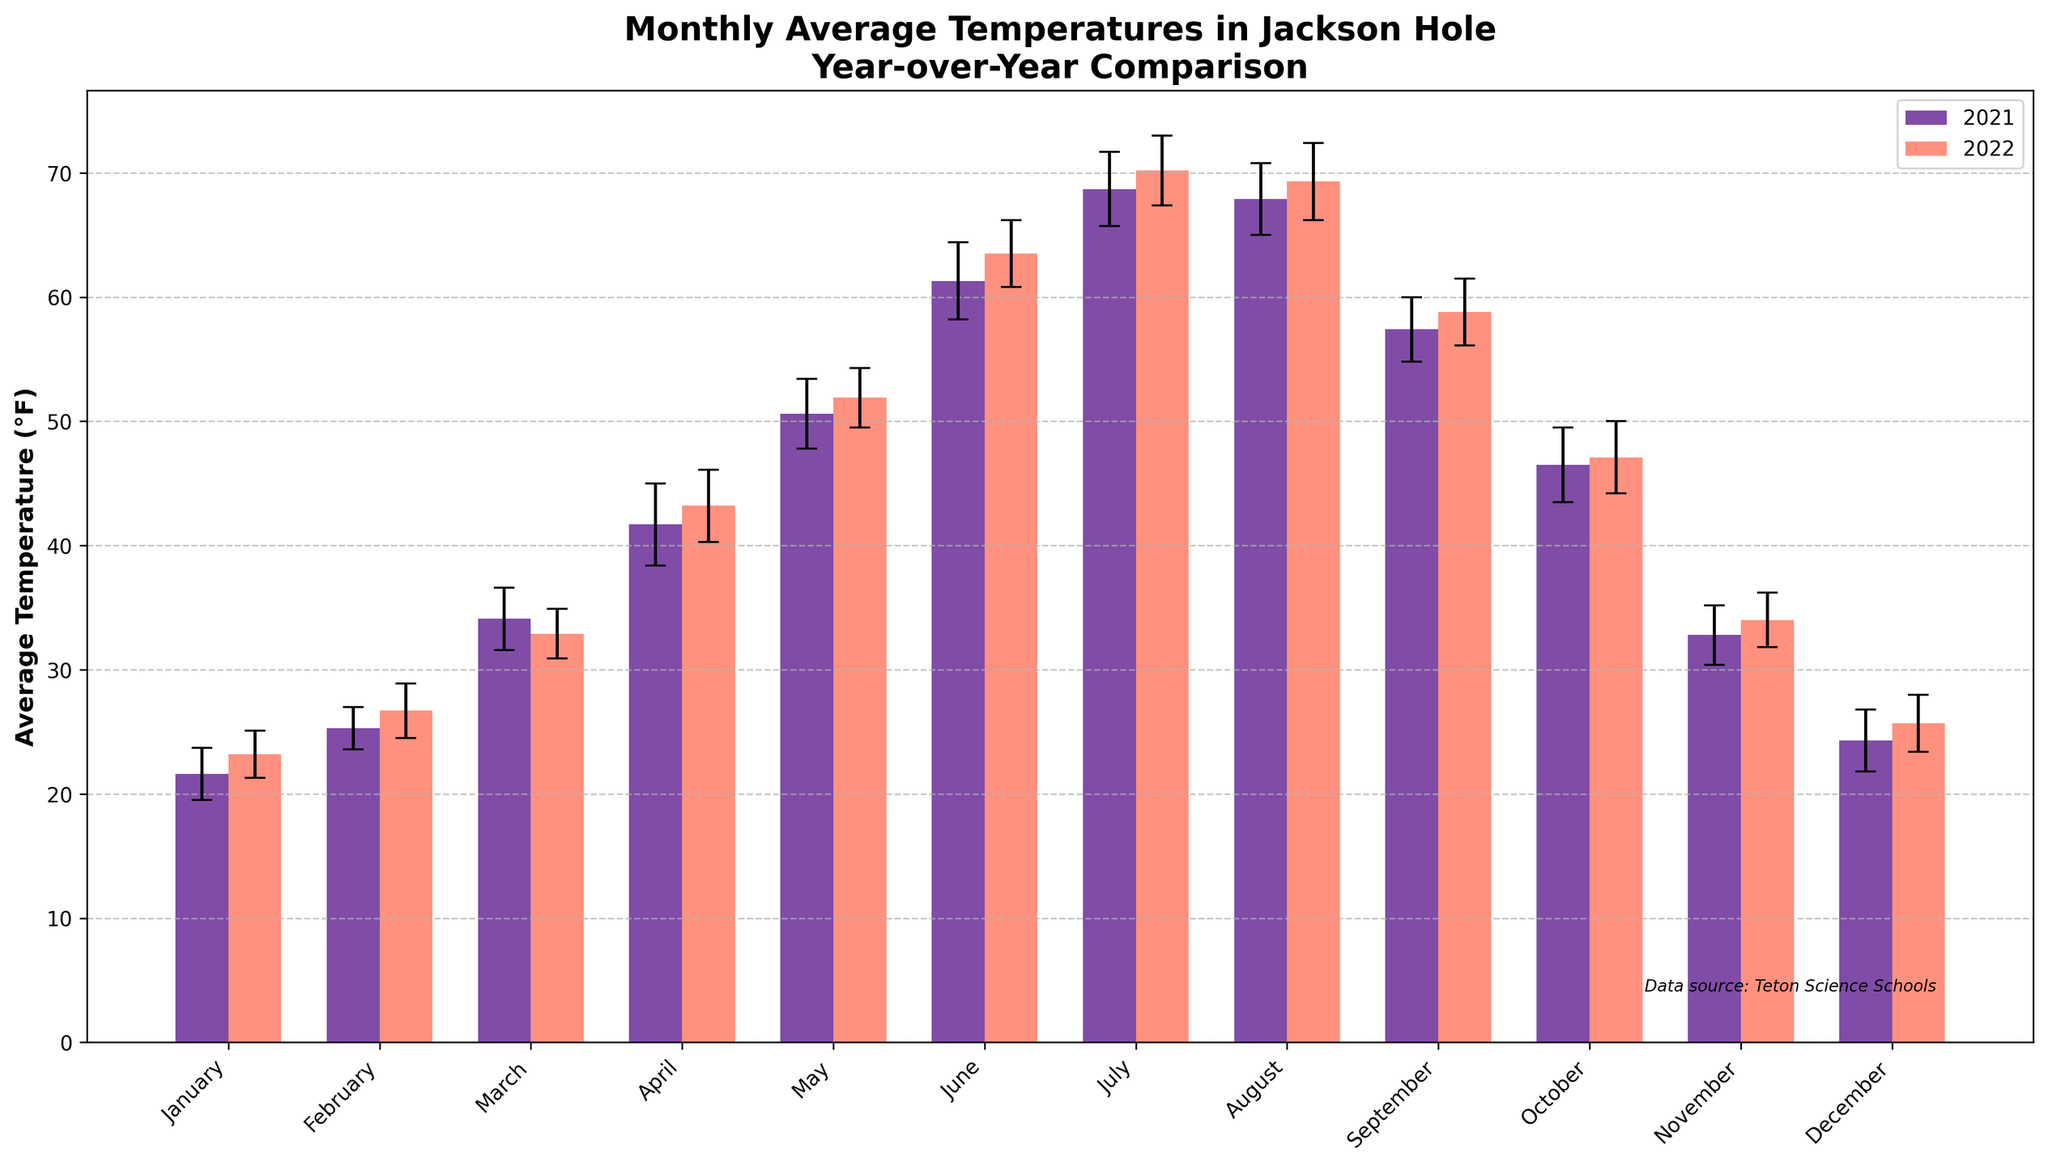What's the title of the plot? The title of the plot is displayed at the top of the figure. It reads "Monthly Average Temperatures in Jackson Hole Year-over-Year Comparison".
Answer: Monthly Average Temperatures in Jackson Hole Year-over-Year Comparison What are the units of the y-axis? The y-axis label indicates the units. It reads "Average Temperature (°F)", so the units are in degrees Fahrenheit.
Answer: degrees Fahrenheit How many months are compared in the figure? The x-axis shows the months, from January to December. Counting these months, we see that all 12 months are included in the comparison.
Answer: 12 Which month had the highest average temperature in 2022? By looking at the heights of the bars for 2022, we can see that July has the highest bar, indicating the highest average temperature in 2022.
Answer: July In which month was the temperature roughly equal in both years? By comparing the heights of the bars for each month, November shows bars of nearly equal height for 2021 and 2022.
Answer: November What was the average temperature for June 2022? By looking at the bar for June 2022, we see that the height of the bar corresponds to an average temperature of around 63.5°F.
Answer: 63.5°F What's the difference in average temperature for December between 2021 and 2022? The bars for December show temperatures of 24.3°F for 2021 and 25.7°F for 2022. The difference is 25.7 - 24.3 = 1.4°F.
Answer: 1.4°F Which year had a higher average temperature in March? Comparing the bars for March, the 2021 bar is higher than the 2022 bar, indicating that 2021 had a higher average temperature.
Answer: 2021 Which months in 2022 showed an increase in average temperature compared to 2021? By comparing each pair of bars, the months January, February, April, May, June, July, August, September, October, November, and December show increases. Only in March, the temperature decreased.
Answer: January, February, April, May, June, July, August, September, October, November, December What is the general trend of monthly temperatures from January to December? Observing the bars from January to December, the temperatures generally rise, peaking around July and then decline towards December, indicating a seasonal pattern with higher temperatures in the summer and lower in the winter.
Answer: Rise to July, then decline 